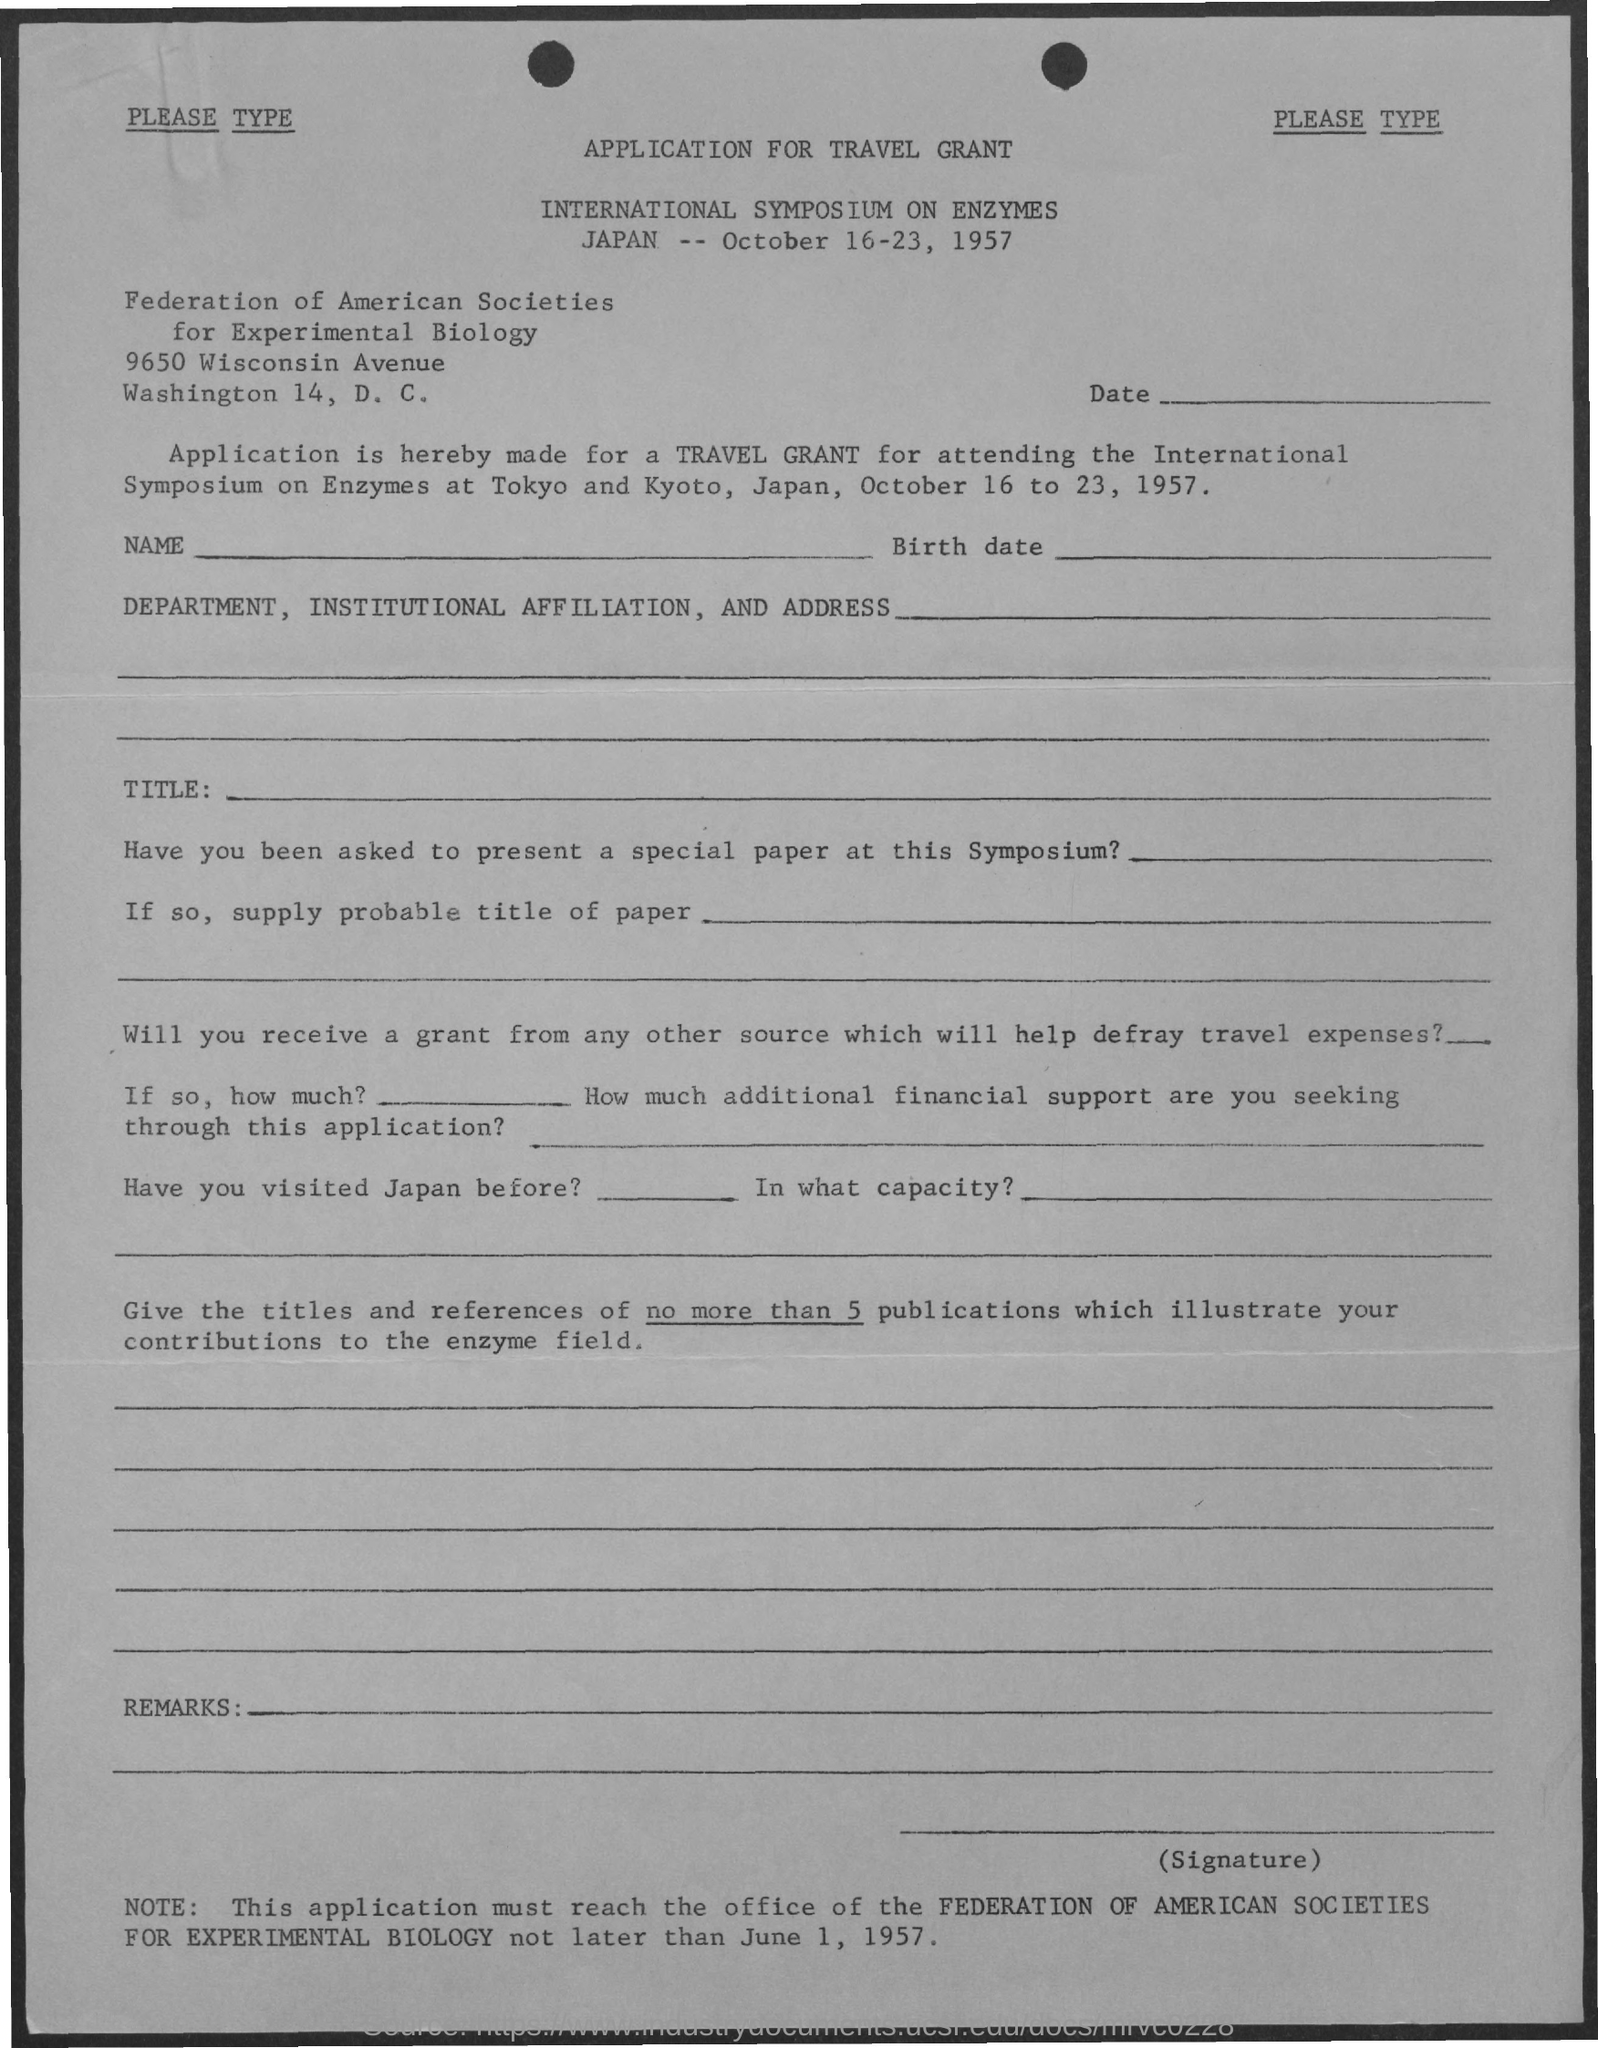The application must reach the office not later than which date
Provide a succinct answer. June 1 ,1957. 